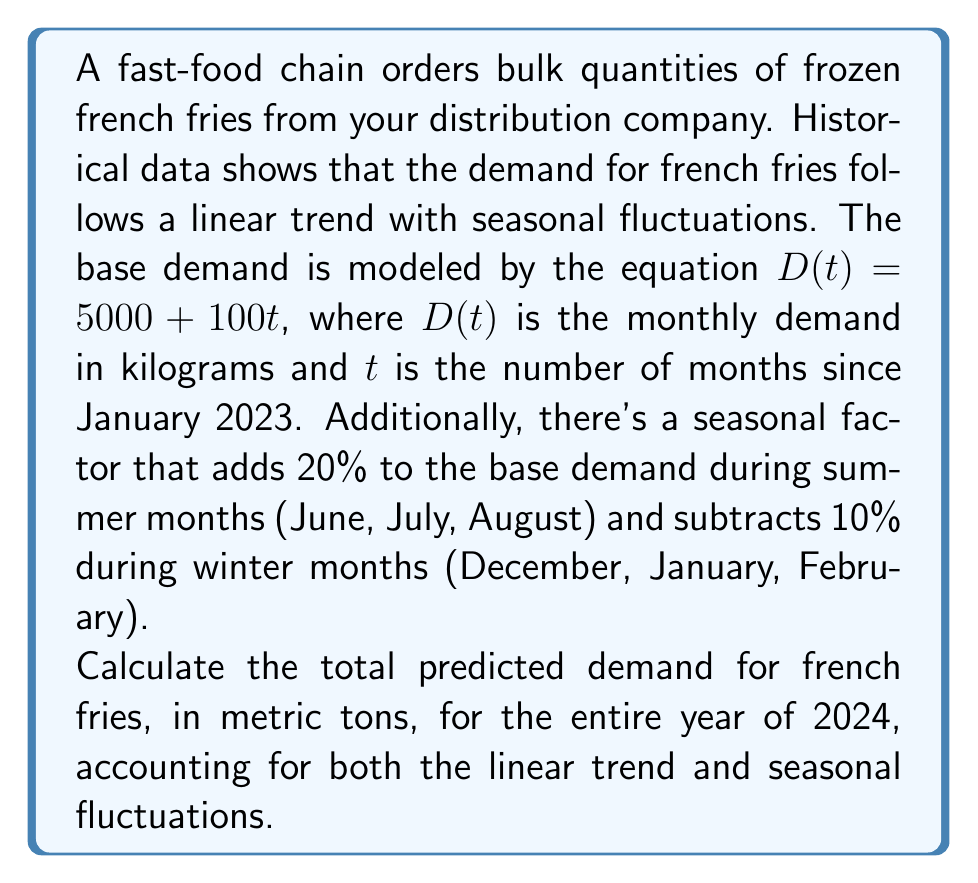Could you help me with this problem? Let's approach this step-by-step:

1) First, we need to calculate the base demand for each month of 2024 using the linear equation:
   $D(t) = 5000 + 100t$

2) January 2024 is the 13th month since January 2023, so we'll start with $t = 13$ and end with $t = 24$ for December 2024.

3) Let's calculate the base demand for each month:

   January ($t = 13$): $D(13) = 5000 + 100(13) = 6300$ kg
   February ($t = 14$): $D(14) = 5000 + 100(14) = 6400$ kg
   ...
   December ($t = 24$): $D(24) = 5000 + 100(24) = 7400$ kg

4) Now, we need to apply the seasonal factors:
   - Winter months (Dec, Jan, Feb): Decrease by 10%
   - Summer months (Jun, Jul, Aug): Increase by 20%
   - Other months: No change

5) Let's calculate the adjusted demand for each month:

   January: $6300 * 0.9 = 5670$ kg
   February: $6400 * 0.9 = 5760$ kg
   March: $6500$ kg
   April: $6600$ kg
   May: $6700$ kg
   June: $6800 * 1.2 = 8160$ kg
   July: $6900 * 1.2 = 8280$ kg
   August: $7000 * 1.2 = 8400$ kg
   September: $7100$ kg
   October: $7200$ kg
   November: $7300$ kg
   December: $7400 * 0.9 = 6660$ kg

6) Sum up all monthly demands:
   $5670 + 5760 + 6500 + 6600 + 6700 + 8160 + 8280 + 8400 + 7100 + 7200 + 7300 + 6660 = 84330$ kg

7) Convert kilograms to metric tons:
   $84330 \text{ kg} = 84.33 \text{ metric tons}$

Therefore, the total predicted demand for french fries in 2024 is 84.33 metric tons.
Answer: 84.33 metric tons 